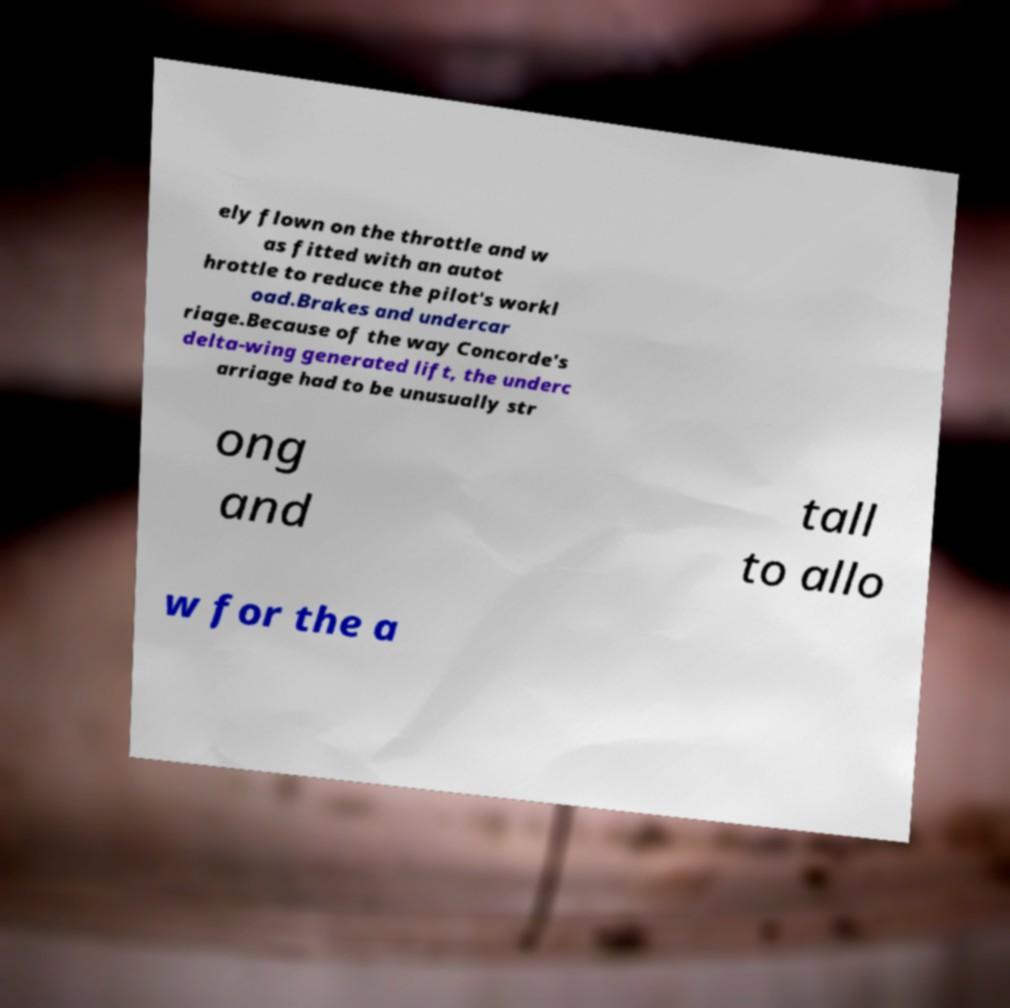Please read and relay the text visible in this image. What does it say? ely flown on the throttle and w as fitted with an autot hrottle to reduce the pilot's workl oad.Brakes and undercar riage.Because of the way Concorde's delta-wing generated lift, the underc arriage had to be unusually str ong and tall to allo w for the a 